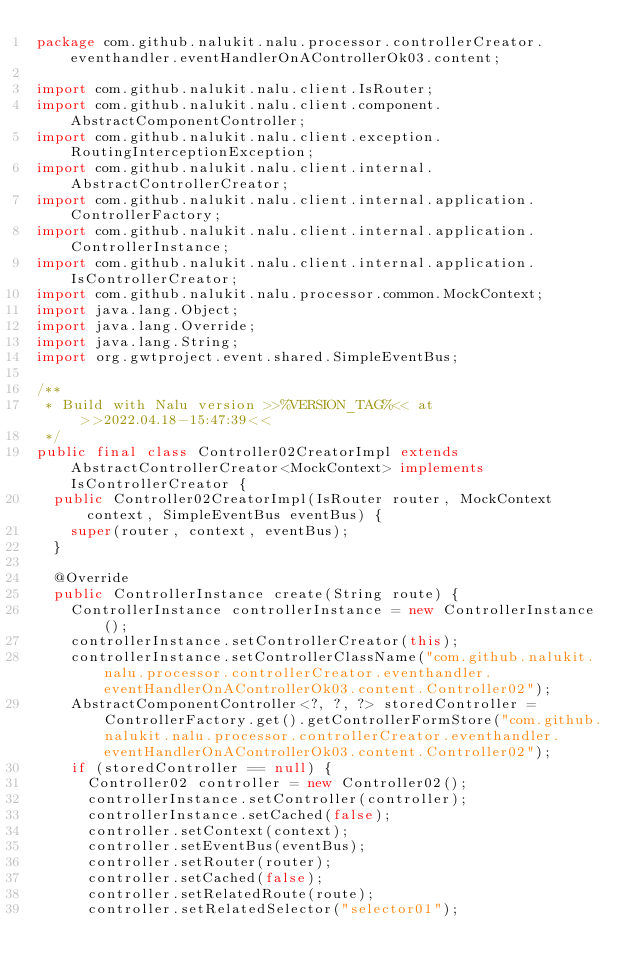<code> <loc_0><loc_0><loc_500><loc_500><_Java_>package com.github.nalukit.nalu.processor.controllerCreator.eventhandler.eventHandlerOnAControllerOk03.content;

import com.github.nalukit.nalu.client.IsRouter;
import com.github.nalukit.nalu.client.component.AbstractComponentController;
import com.github.nalukit.nalu.client.exception.RoutingInterceptionException;
import com.github.nalukit.nalu.client.internal.AbstractControllerCreator;
import com.github.nalukit.nalu.client.internal.application.ControllerFactory;
import com.github.nalukit.nalu.client.internal.application.ControllerInstance;
import com.github.nalukit.nalu.client.internal.application.IsControllerCreator;
import com.github.nalukit.nalu.processor.common.MockContext;
import java.lang.Object;
import java.lang.Override;
import java.lang.String;
import org.gwtproject.event.shared.SimpleEventBus;

/**
 * Build with Nalu version >>%VERSION_TAG%<< at >>2022.04.18-15:47:39<<
 */
public final class Controller02CreatorImpl extends AbstractControllerCreator<MockContext> implements IsControllerCreator {
  public Controller02CreatorImpl(IsRouter router, MockContext context, SimpleEventBus eventBus) {
    super(router, context, eventBus);
  }

  @Override
  public ControllerInstance create(String route) {
    ControllerInstance controllerInstance = new ControllerInstance();
    controllerInstance.setControllerCreator(this);
    controllerInstance.setControllerClassName("com.github.nalukit.nalu.processor.controllerCreator.eventhandler.eventHandlerOnAControllerOk03.content.Controller02");
    AbstractComponentController<?, ?, ?> storedController = ControllerFactory.get().getControllerFormStore("com.github.nalukit.nalu.processor.controllerCreator.eventhandler.eventHandlerOnAControllerOk03.content.Controller02");
    if (storedController == null) {
      Controller02 controller = new Controller02();
      controllerInstance.setController(controller);
      controllerInstance.setCached(false);
      controller.setContext(context);
      controller.setEventBus(eventBus);
      controller.setRouter(router);
      controller.setCached(false);
      controller.setRelatedRoute(route);
      controller.setRelatedSelector("selector01");</code> 